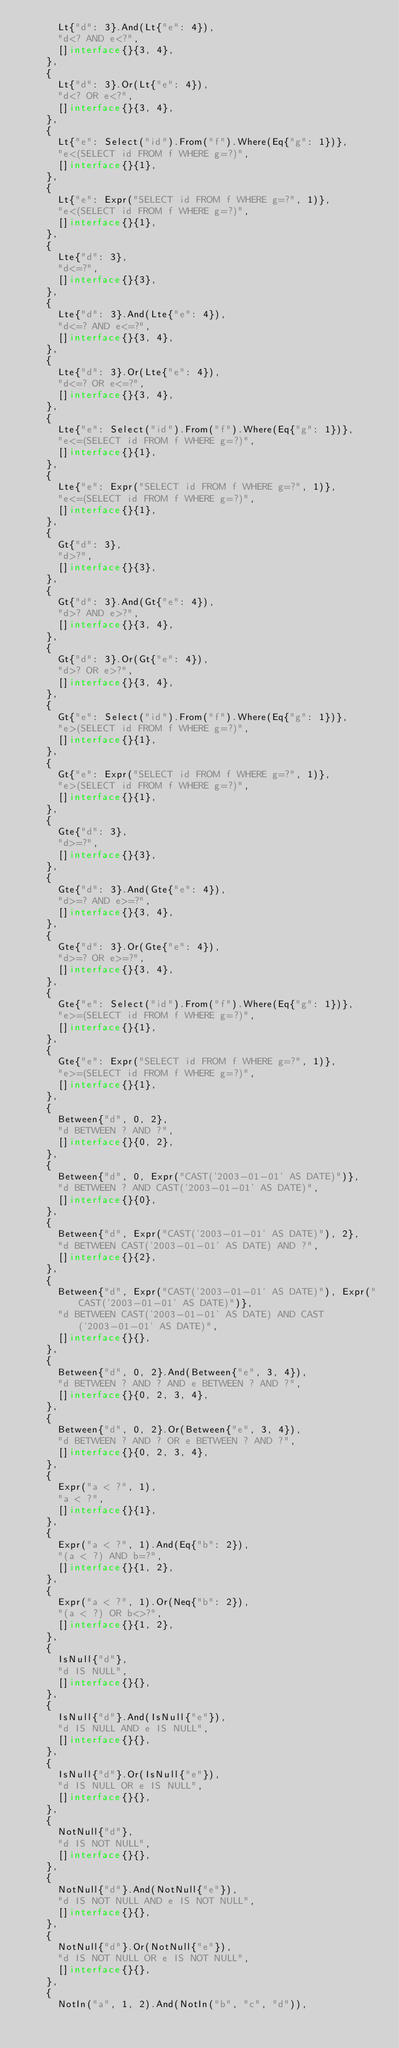Convert code to text. <code><loc_0><loc_0><loc_500><loc_500><_Go_>			Lt{"d": 3}.And(Lt{"e": 4}),
			"d<? AND e<?",
			[]interface{}{3, 4},
		},
		{
			Lt{"d": 3}.Or(Lt{"e": 4}),
			"d<? OR e<?",
			[]interface{}{3, 4},
		},
		{
			Lt{"e": Select("id").From("f").Where(Eq{"g": 1})},
			"e<(SELECT id FROM f WHERE g=?)",
			[]interface{}{1},
		},
		{
			Lt{"e": Expr("SELECT id FROM f WHERE g=?", 1)},
			"e<(SELECT id FROM f WHERE g=?)",
			[]interface{}{1},
		},
		{
			Lte{"d": 3},
			"d<=?",
			[]interface{}{3},
		},
		{
			Lte{"d": 3}.And(Lte{"e": 4}),
			"d<=? AND e<=?",
			[]interface{}{3, 4},
		},
		{
			Lte{"d": 3}.Or(Lte{"e": 4}),
			"d<=? OR e<=?",
			[]interface{}{3, 4},
		},
		{
			Lte{"e": Select("id").From("f").Where(Eq{"g": 1})},
			"e<=(SELECT id FROM f WHERE g=?)",
			[]interface{}{1},
		},
		{
			Lte{"e": Expr("SELECT id FROM f WHERE g=?", 1)},
			"e<=(SELECT id FROM f WHERE g=?)",
			[]interface{}{1},
		},
		{
			Gt{"d": 3},
			"d>?",
			[]interface{}{3},
		},
		{
			Gt{"d": 3}.And(Gt{"e": 4}),
			"d>? AND e>?",
			[]interface{}{3, 4},
		},
		{
			Gt{"d": 3}.Or(Gt{"e": 4}),
			"d>? OR e>?",
			[]interface{}{3, 4},
		},
		{
			Gt{"e": Select("id").From("f").Where(Eq{"g": 1})},
			"e>(SELECT id FROM f WHERE g=?)",
			[]interface{}{1},
		},
		{
			Gt{"e": Expr("SELECT id FROM f WHERE g=?", 1)},
			"e>(SELECT id FROM f WHERE g=?)",
			[]interface{}{1},
		},
		{
			Gte{"d": 3},
			"d>=?",
			[]interface{}{3},
		},
		{
			Gte{"d": 3}.And(Gte{"e": 4}),
			"d>=? AND e>=?",
			[]interface{}{3, 4},
		},
		{
			Gte{"d": 3}.Or(Gte{"e": 4}),
			"d>=? OR e>=?",
			[]interface{}{3, 4},
		},
		{
			Gte{"e": Select("id").From("f").Where(Eq{"g": 1})},
			"e>=(SELECT id FROM f WHERE g=?)",
			[]interface{}{1},
		},
		{
			Gte{"e": Expr("SELECT id FROM f WHERE g=?", 1)},
			"e>=(SELECT id FROM f WHERE g=?)",
			[]interface{}{1},
		},
		{
			Between{"d", 0, 2},
			"d BETWEEN ? AND ?",
			[]interface{}{0, 2},
		},
		{
			Between{"d", 0, Expr("CAST('2003-01-01' AS DATE)")},
			"d BETWEEN ? AND CAST('2003-01-01' AS DATE)",
			[]interface{}{0},
		},
		{
			Between{"d", Expr("CAST('2003-01-01' AS DATE)"), 2},
			"d BETWEEN CAST('2003-01-01' AS DATE) AND ?",
			[]interface{}{2},
		},
		{
			Between{"d", Expr("CAST('2003-01-01' AS DATE)"), Expr("CAST('2003-01-01' AS DATE)")},
			"d BETWEEN CAST('2003-01-01' AS DATE) AND CAST('2003-01-01' AS DATE)",
			[]interface{}{},
		},
		{
			Between{"d", 0, 2}.And(Between{"e", 3, 4}),
			"d BETWEEN ? AND ? AND e BETWEEN ? AND ?",
			[]interface{}{0, 2, 3, 4},
		},
		{
			Between{"d", 0, 2}.Or(Between{"e", 3, 4}),
			"d BETWEEN ? AND ? OR e BETWEEN ? AND ?",
			[]interface{}{0, 2, 3, 4},
		},
		{
			Expr("a < ?", 1),
			"a < ?",
			[]interface{}{1},
		},
		{
			Expr("a < ?", 1).And(Eq{"b": 2}),
			"(a < ?) AND b=?",
			[]interface{}{1, 2},
		},
		{
			Expr("a < ?", 1).Or(Neq{"b": 2}),
			"(a < ?) OR b<>?",
			[]interface{}{1, 2},
		},
		{
			IsNull{"d"},
			"d IS NULL",
			[]interface{}{},
		},
		{
			IsNull{"d"}.And(IsNull{"e"}),
			"d IS NULL AND e IS NULL",
			[]interface{}{},
		},
		{
			IsNull{"d"}.Or(IsNull{"e"}),
			"d IS NULL OR e IS NULL",
			[]interface{}{},
		},
		{
			NotNull{"d"},
			"d IS NOT NULL",
			[]interface{}{},
		},
		{
			NotNull{"d"}.And(NotNull{"e"}),
			"d IS NOT NULL AND e IS NOT NULL",
			[]interface{}{},
		},
		{
			NotNull{"d"}.Or(NotNull{"e"}),
			"d IS NOT NULL OR e IS NOT NULL",
			[]interface{}{},
		},
		{
			NotIn("a", 1, 2).And(NotIn("b", "c", "d")),</code> 